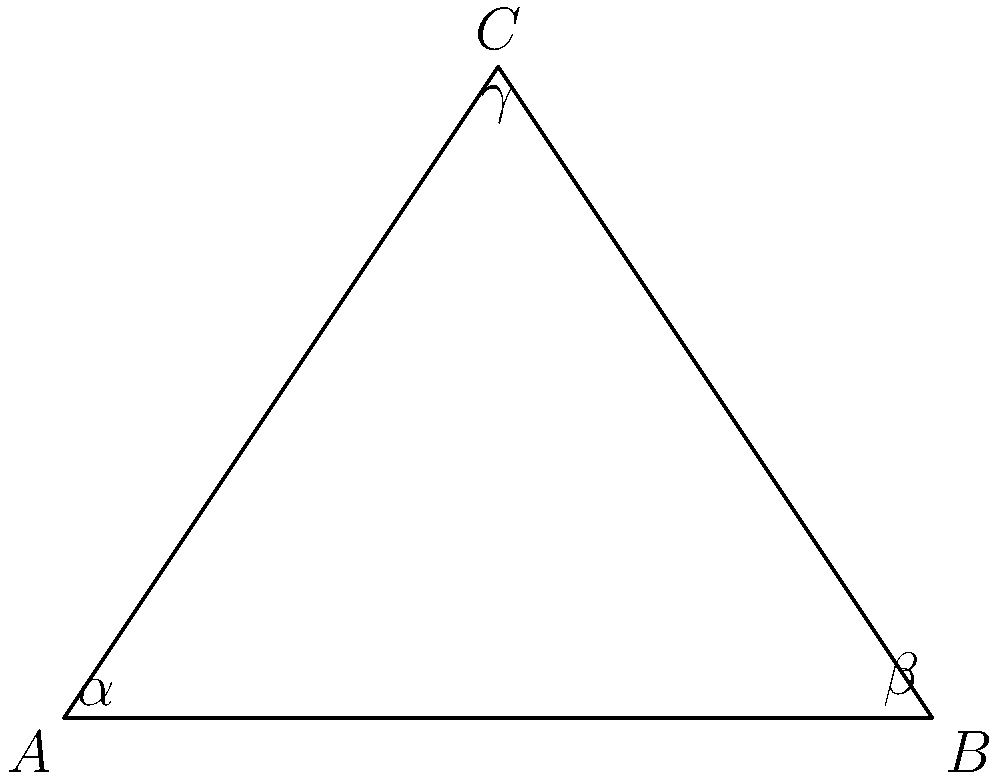As a real estate developer in Stateline, Nevada, you're working on a unique property with non-Euclidean geometry. You have a hyperbolic triangle with angles $\alpha = 45°$, $\beta = 60°$, and $\gamma = 30°$. Given that the area of a hyperbolic triangle is $A = (\alpha + \beta + \gamma - \pi)R^2$, where $R$ is the radius of curvature (assume $R = 1$), calculate the area of this triangle. To solve this problem, let's follow these steps:

1) First, we need to convert the given angles from degrees to radians:
   $\alpha = 45° = \frac{\pi}{4}$ radians
   $\beta = 60° = \frac{\pi}{3}$ radians
   $\gamma = 30° = \frac{\pi}{6}$ radians

2) Now, we can substitute these values into the formula:
   $A = (\alpha + \beta + \gamma - \pi)R^2$

3) Substituting the values:
   $A = (\frac{\pi}{4} + \frac{\pi}{3} + \frac{\pi}{6} - \pi) \cdot 1^2$

4) Simplifying the expression inside the parentheses:
   $A = (\frac{3\pi}{12} + \frac{4\pi}{12} + \frac{2\pi}{12} - \frac{12\pi}{12})$

5) Adding the fractions:
   $A = (\frac{9\pi}{12} - \frac{12\pi}{12})$

6) Simplifying:
   $A = -\frac{3\pi}{12} = -\frac{\pi}{4}$

7) Therefore, the area of the hyperbolic triangle is $-\frac{\pi}{4}$ square units.
Answer: $-\frac{\pi}{4}$ square units 